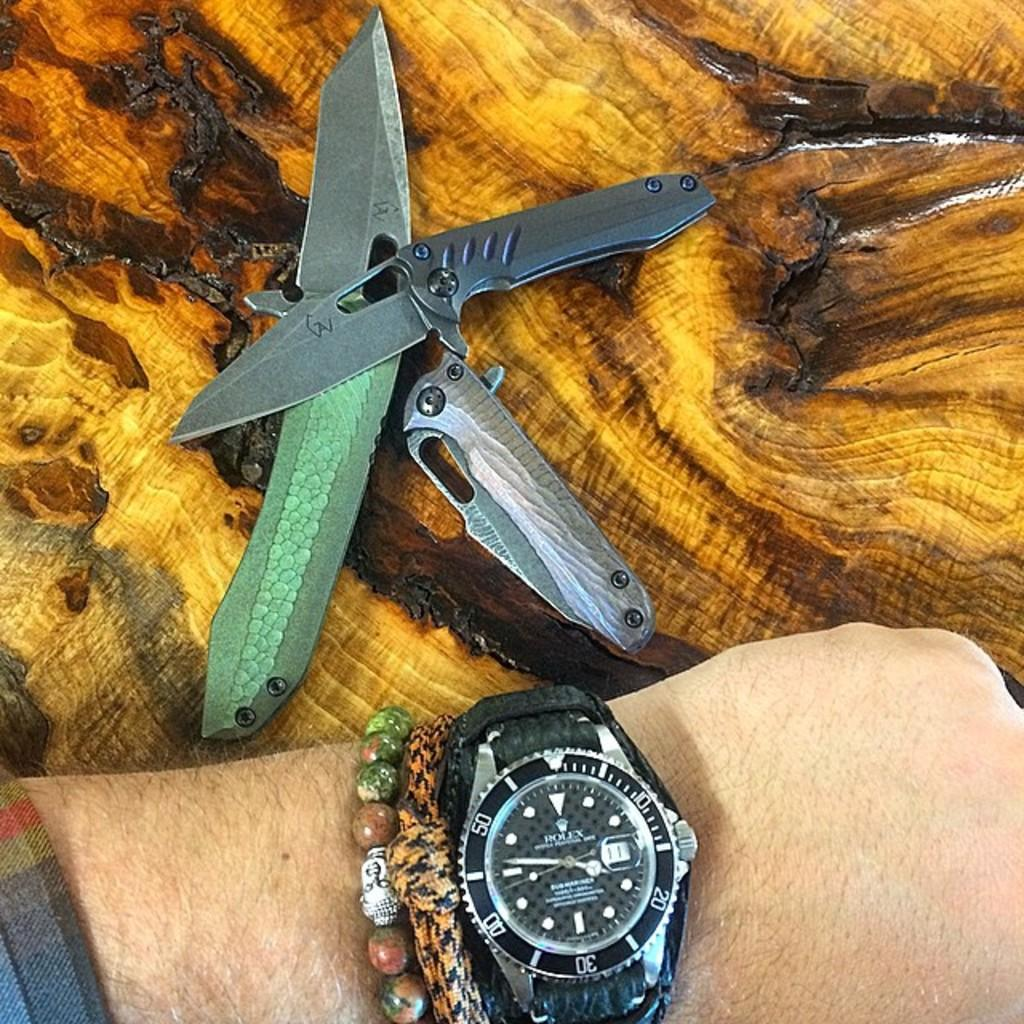<image>
Offer a succinct explanation of the picture presented. A close up of a rolex watch on a wrist next to a swiss army knife. 